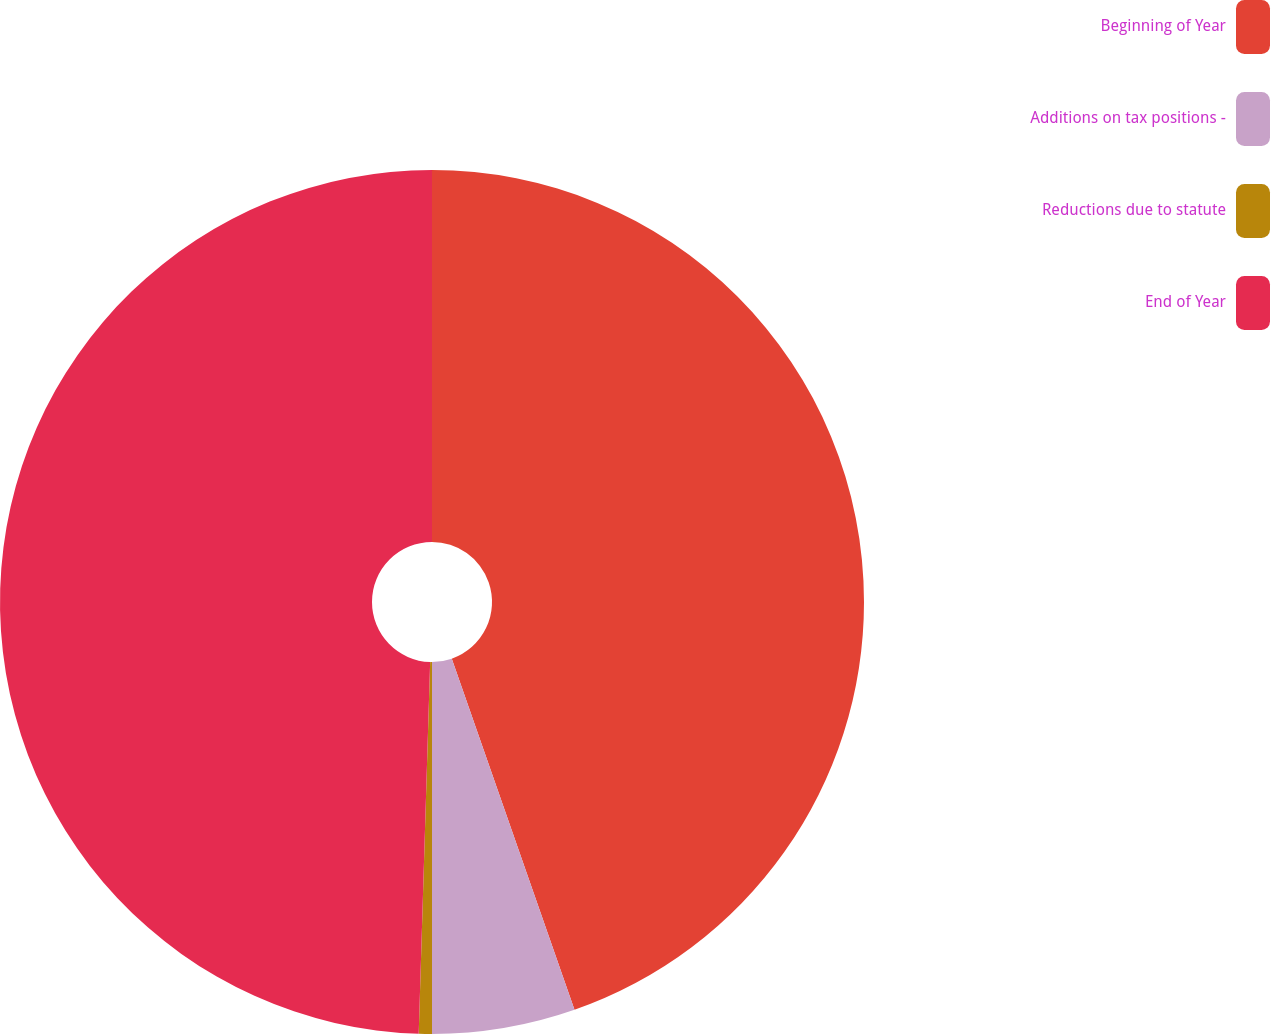Convert chart. <chart><loc_0><loc_0><loc_500><loc_500><pie_chart><fcel>Beginning of Year<fcel>Additions on tax positions -<fcel>Reductions due to statute<fcel>End of Year<nl><fcel>44.65%<fcel>5.35%<fcel>0.49%<fcel>49.51%<nl></chart> 